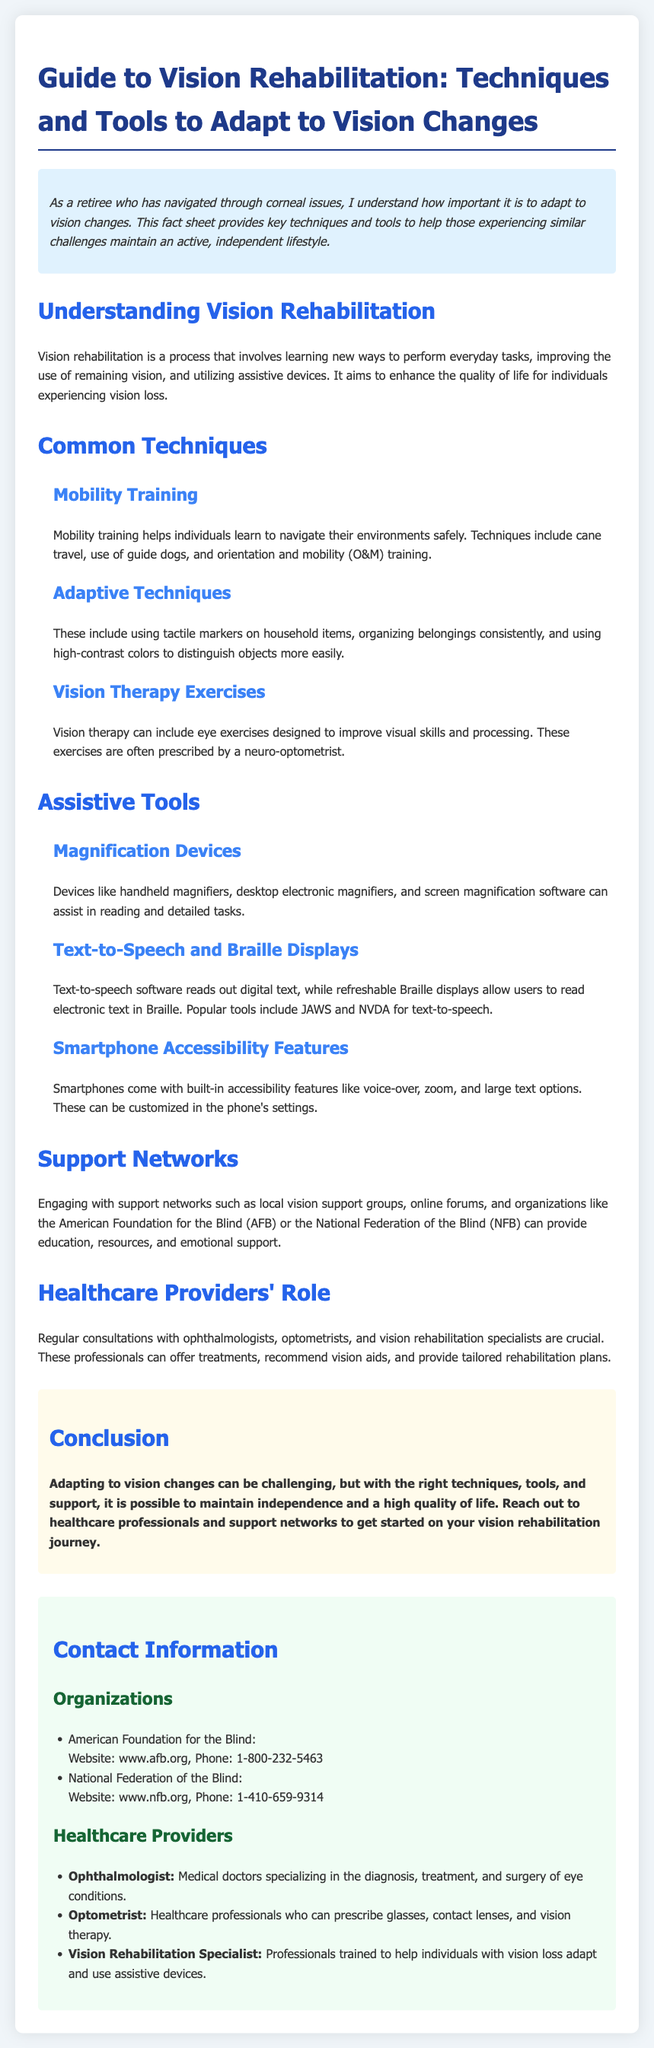What is the purpose of vision rehabilitation? Vision rehabilitation aims to enhance the quality of life for individuals experiencing vision loss by learning new ways to perform everyday tasks and improving the use of remaining vision.
Answer: Enhancing quality of life What is one mobility training technique mentioned? Cane travel is listed as one of the techniques used in mobility training to help individuals navigate their environments safely.
Answer: Cane travel Which organization can be contacted for blind support in the U.S.? The American Foundation for the Blind is highlighted as an organization that provides education and resources for individuals with vision loss.
Answer: American Foundation for the Blind What type of healthcare professional can prescribe vision therapy? A neuro-optometrist is specifically mentioned as a healthcare professional who can prescribe vision therapy exercises designed to improve visual skills.
Answer: Neuro-optometrist How can smartphones assist individuals with vision changes? Smartphones offer built-in accessibility features such as voice-over, zoom, and large text options, which can help users navigate their devices more easily.
Answer: Accessibility features What should individuals do to adapt to vision changes? Individuals are encouraged to engage with support networks and consult healthcare providers for tailored rehabilitation plans to maintain independence.
Answer: Engage with support networks What is one type of assistive tool listed for reading? Handheld magnifiers are mentioned as a type of assistive tool that can assist individuals in reading and detailed tasks.
Answer: Handheld magnifiers Which professionals are crucial for regular consultations regarding vision rehabilitation? Ophthalmologists, optometrists, and vision rehabilitation specialists are noted as crucial healthcare providers for consultations related to vision rehabilitation.
Answer: Ophthalmologists, optometrists, vision rehabilitation specialists 